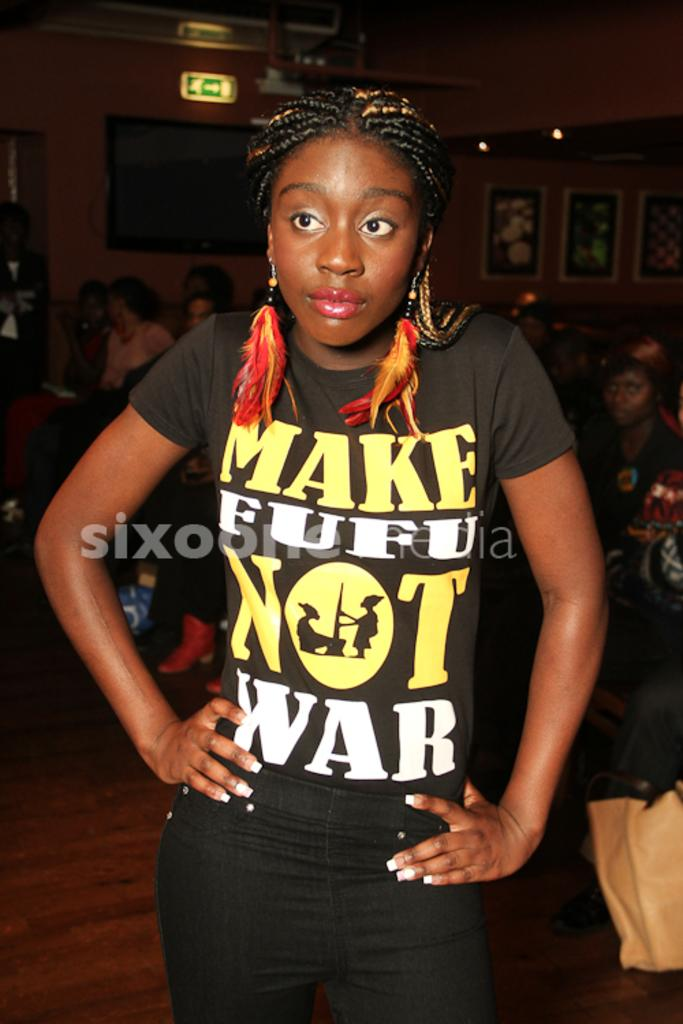<image>
Share a concise interpretation of the image provided. A young lady wears a shirt telling you to make fufu not war. 